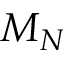Convert formula to latex. <formula><loc_0><loc_0><loc_500><loc_500>M _ { N }</formula> 